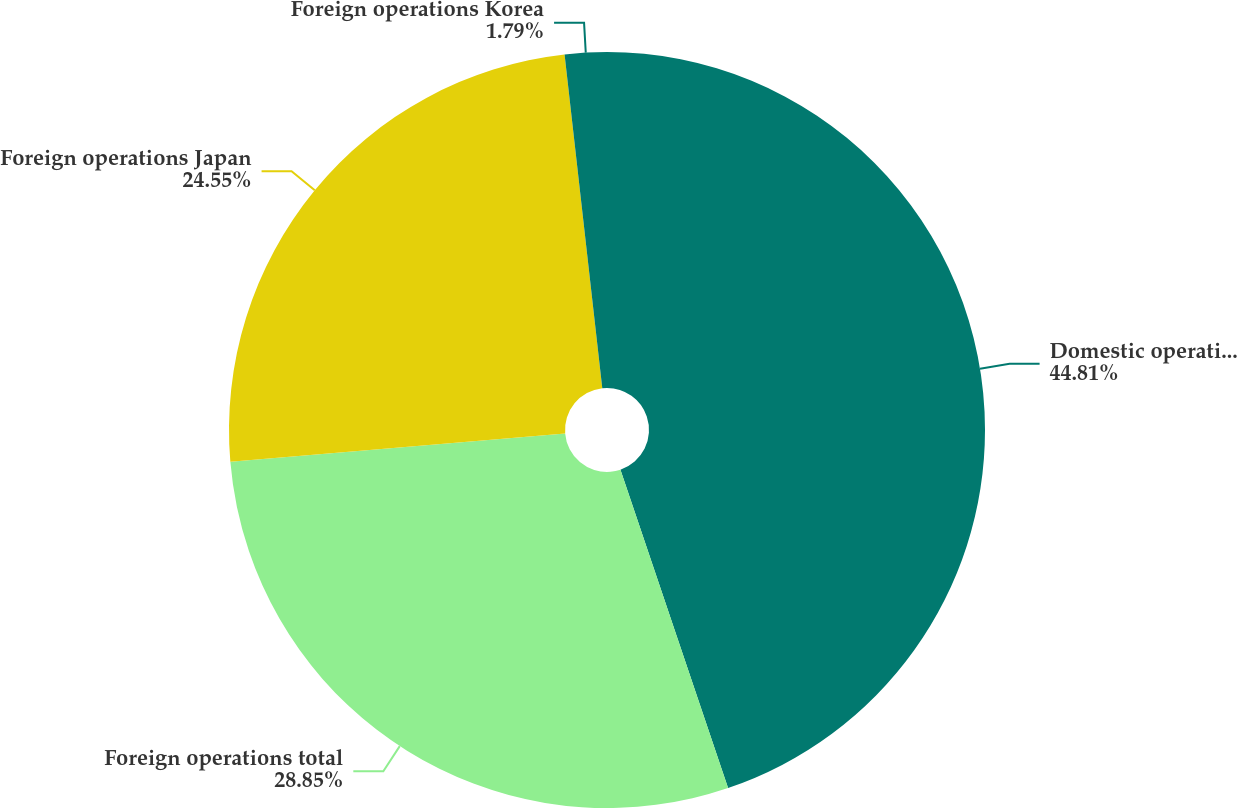Convert chart. <chart><loc_0><loc_0><loc_500><loc_500><pie_chart><fcel>Domestic operations<fcel>Foreign operations total<fcel>Foreign operations Japan<fcel>Foreign operations Korea<nl><fcel>44.81%<fcel>28.85%<fcel>24.55%<fcel>1.79%<nl></chart> 